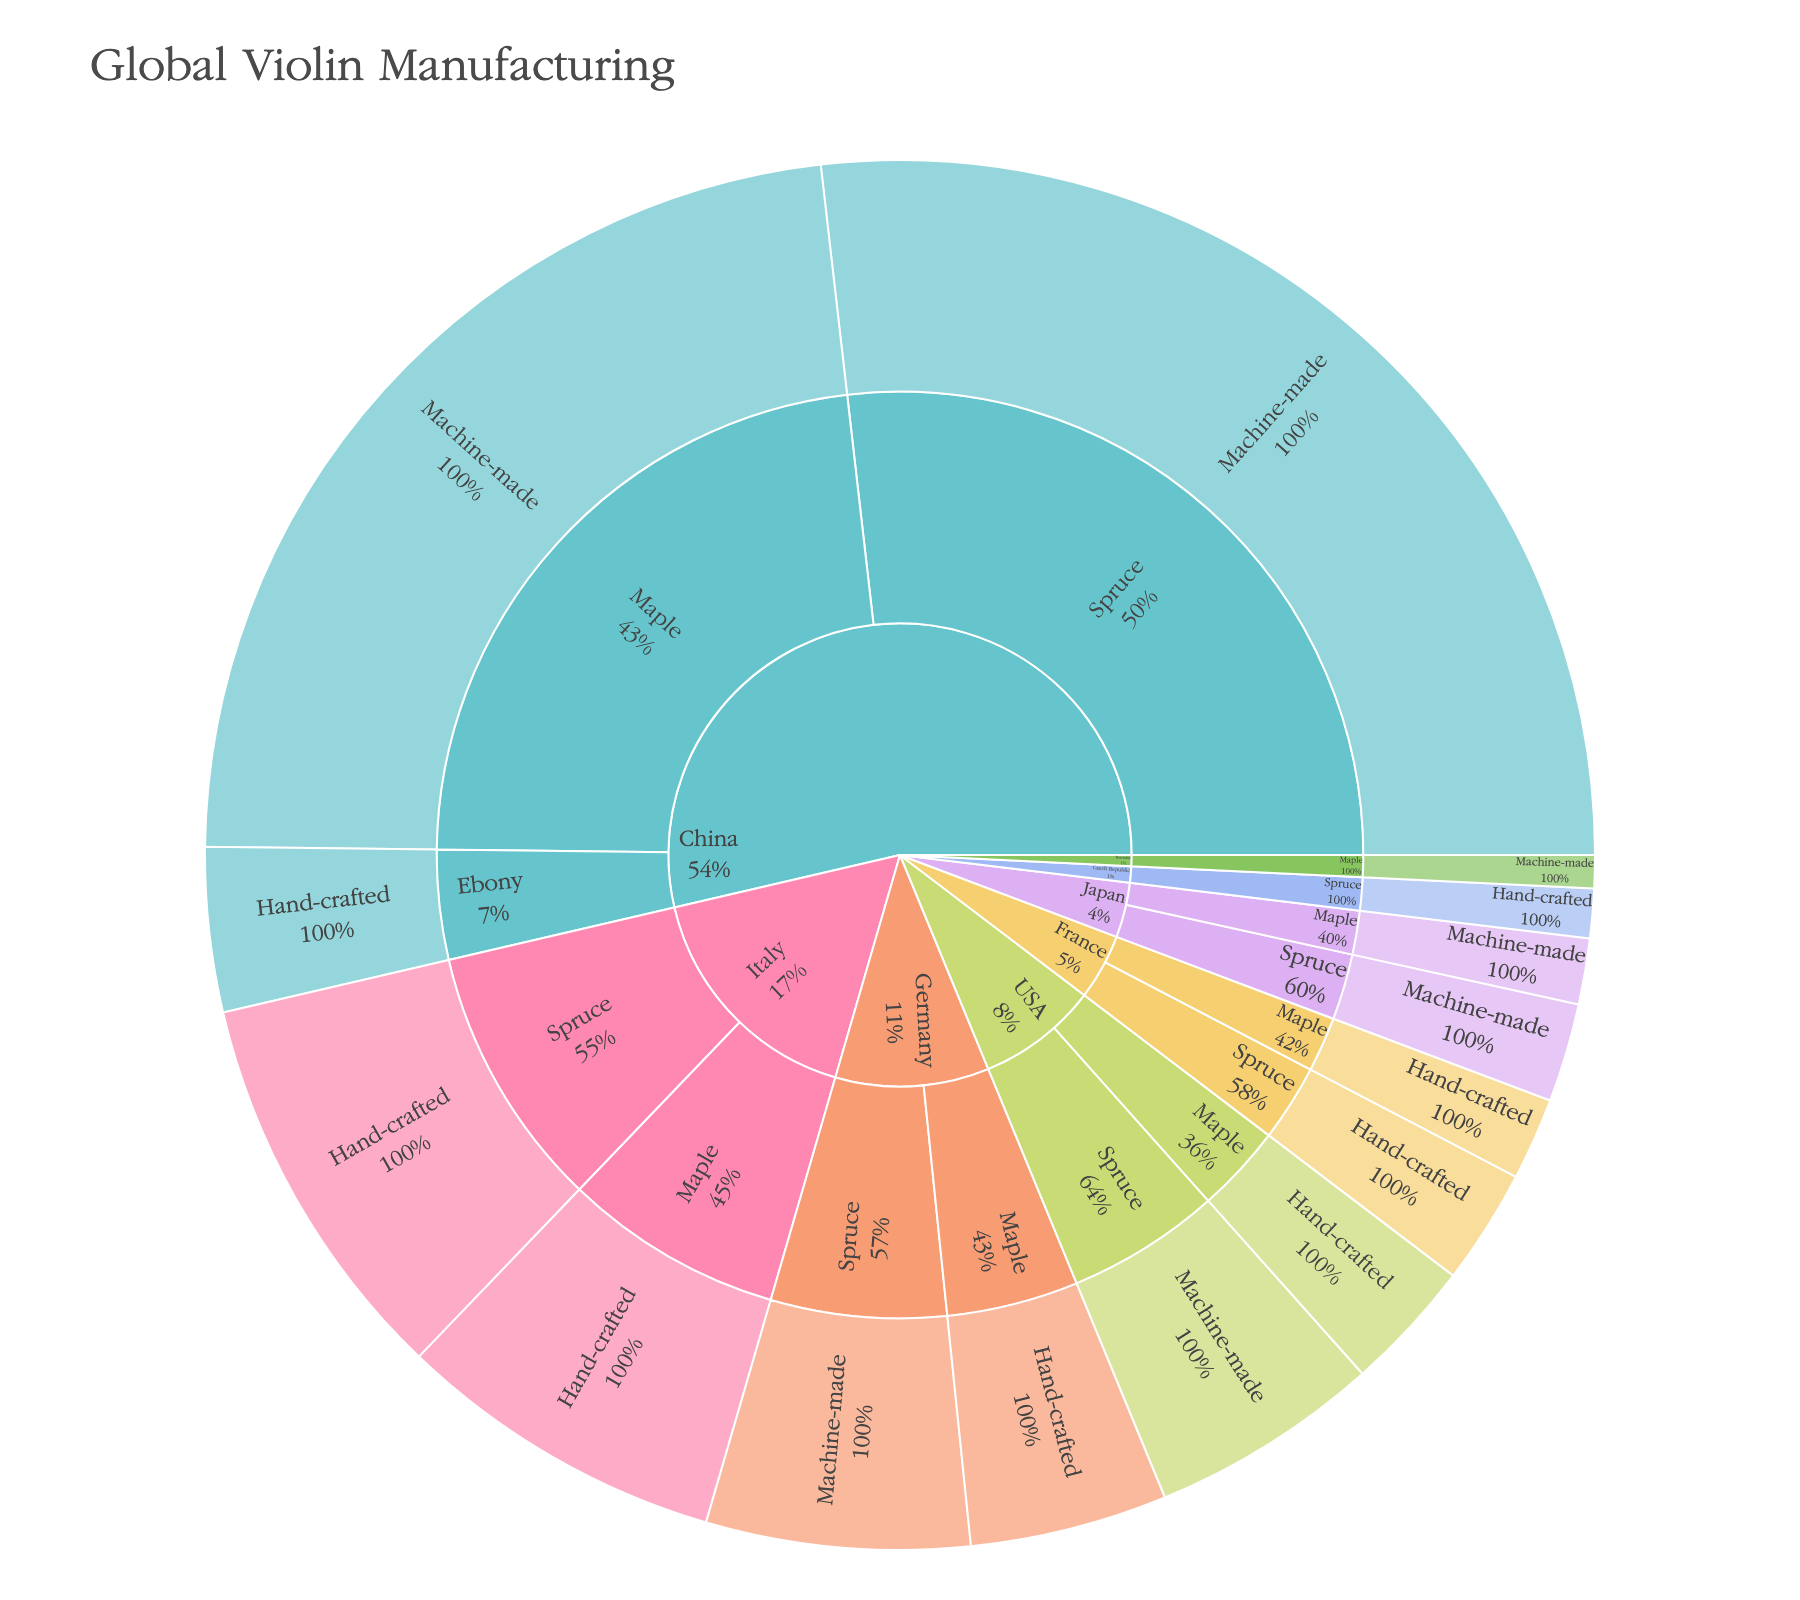How many violins are machine-made in China? The inner ring of the Sunburst Plot represents countries, and the next ring represents the wood types. For China, if we look to machine-made Spruce and Maple, we sum their values (3500 + 3000).
Answer: 6500 Which country produces the most hand-crafted violins? Look for the country sections with hand-crafted methods within their segments and compare: China (Ebony 500), Italy (Spruce 1200 + Maple 1000), Germany (Maple 600), USA (Maple 400), France (Spruce 350 + Maple 250), Czech Republic (Spruce 150). Italy has the highest total.
Answer: Italy What is the total number of violins made from Spruce wood? Sum up the values for Spruce under each country: China (3500), Italy (1200), Germany (800), USA (700), France (350), Japan (300), Czech Republic (150). Adding these gives 7000.
Answer: 7000 Compare the production of machine-made to hand-crafted violins. Which is higher? Sum the values of machine-made and hand-crafted across all countries. Machine-made: (3500+3000+800+700+300+100 = 8400) and Hand-crafted: (500+1200+1000+600+400+350+250+150 = 4450). Machine-made is higher.
Answer: Machine-made Which country uses Ebony wood for violin manufacturing? Follow the segment for Ebony wood in the plot to identify the associated country.
Answer: China What is the combined number of hand-crafted violins in Germany and USA? Sum the hand-crafted violins for Germany (Maple 600) and USA (Maple 400).
Answer: 1000 How many violins are produced using Maple wood in Japan? Refer to the Maple segment under Japan and sum the production methods (Machine-made 200).
Answer: 200 Which wood type is least used in global violin manufacturing? Compare the total values for each wood type by summing their segments: Spruce (7000), Maple (5050), Ebony (500). Ebony has the smallest total.
Answer: Ebony What percentage of France's violin production is hand-crafted using Spruce wood? Sum up France's total production (350 for Spruce + 250 for Maple = 600). The percentage for Spruce (350 / 600 * 100) is approximately 58.3%.
Answer: 58.3% Which production method is most common for Maple wood violins in the dataset? Sum up the values for Maple violins under machine-made and hand-crafted. Machine-made (China 3000 + Romania 100 = 3100), Hand-crafted (Italy 1000 + Germany 600 + USA 400 + France 250 = 2250). So, Machine-made is more common.
Answer: Machine-made 